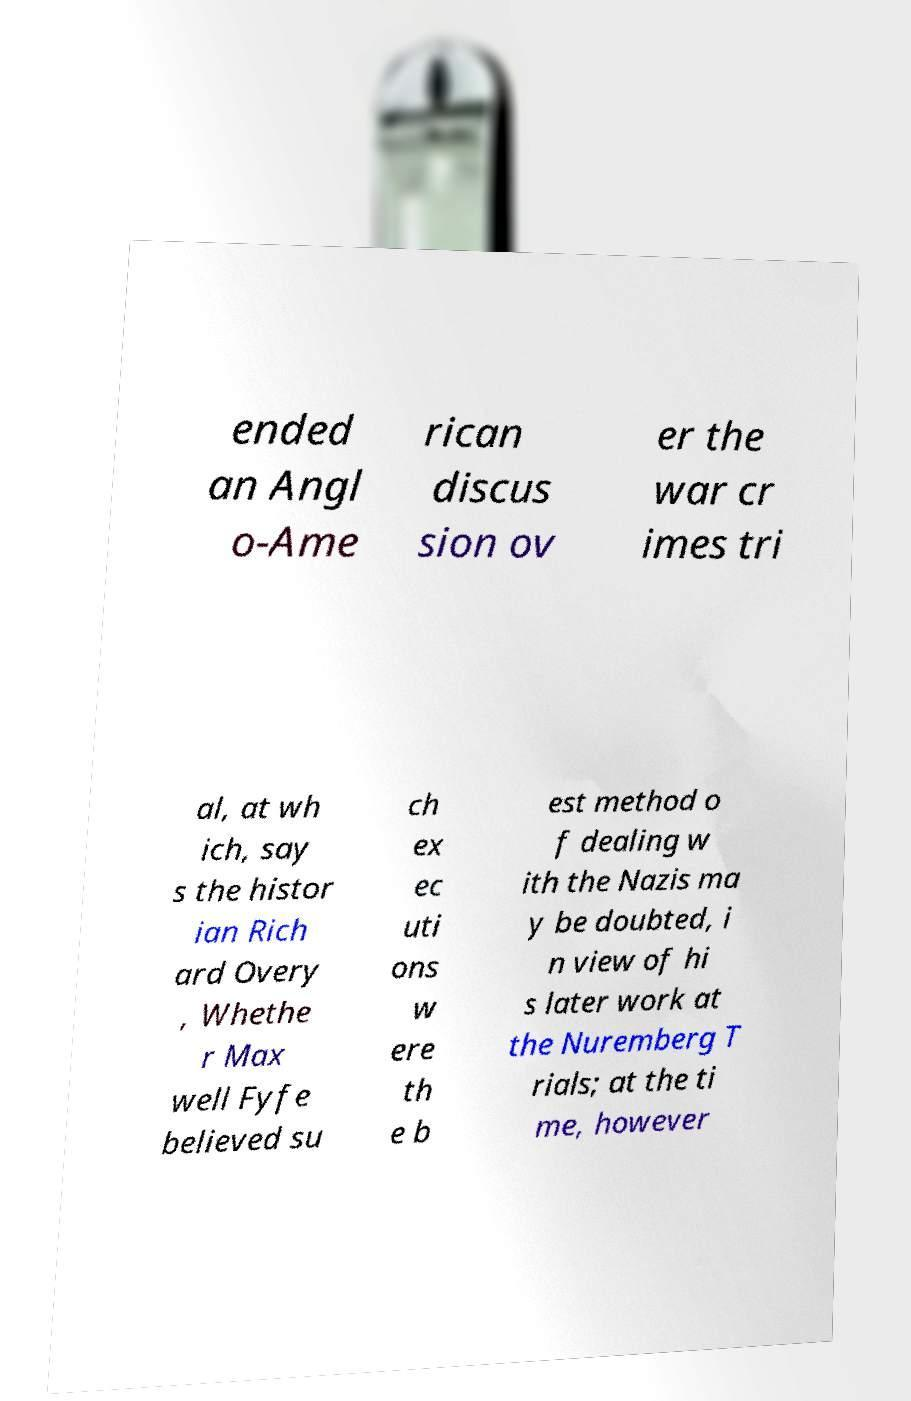For documentation purposes, I need the text within this image transcribed. Could you provide that? ended an Angl o-Ame rican discus sion ov er the war cr imes tri al, at wh ich, say s the histor ian Rich ard Overy , Whethe r Max well Fyfe believed su ch ex ec uti ons w ere th e b est method o f dealing w ith the Nazis ma y be doubted, i n view of hi s later work at the Nuremberg T rials; at the ti me, however 